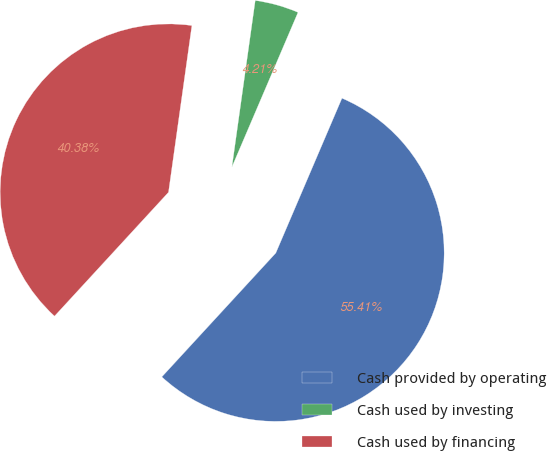<chart> <loc_0><loc_0><loc_500><loc_500><pie_chart><fcel>Cash provided by operating<fcel>Cash used by investing<fcel>Cash used by financing<nl><fcel>55.41%<fcel>4.21%<fcel>40.38%<nl></chart> 